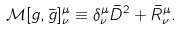<formula> <loc_0><loc_0><loc_500><loc_500>\mathcal { M } [ g , \bar { g } ] ^ { \mu } _ { \nu } \equiv \delta ^ { \mu } _ { \nu } \bar { D } ^ { 2 } + \bar { R } ^ { \mu } _ { \nu } .</formula> 